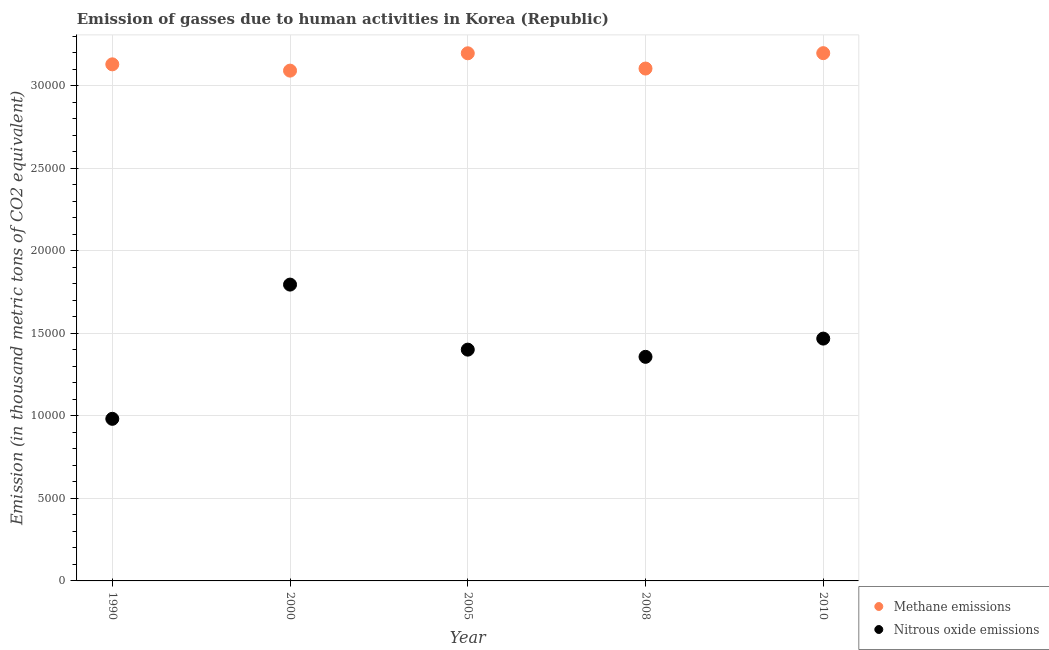How many different coloured dotlines are there?
Offer a terse response. 2. Is the number of dotlines equal to the number of legend labels?
Your answer should be compact. Yes. What is the amount of nitrous oxide emissions in 1990?
Give a very brief answer. 9823.4. Across all years, what is the maximum amount of nitrous oxide emissions?
Offer a terse response. 1.80e+04. Across all years, what is the minimum amount of nitrous oxide emissions?
Make the answer very short. 9823.4. In which year was the amount of nitrous oxide emissions maximum?
Provide a short and direct response. 2000. What is the total amount of methane emissions in the graph?
Offer a very short reply. 1.57e+05. What is the difference between the amount of methane emissions in 2000 and that in 2008?
Your answer should be compact. -126.5. What is the difference between the amount of nitrous oxide emissions in 1990 and the amount of methane emissions in 2000?
Your answer should be compact. -2.11e+04. What is the average amount of nitrous oxide emissions per year?
Ensure brevity in your answer.  1.40e+04. In the year 2008, what is the difference between the amount of methane emissions and amount of nitrous oxide emissions?
Your answer should be very brief. 1.75e+04. What is the ratio of the amount of methane emissions in 1990 to that in 2010?
Your answer should be very brief. 0.98. What is the difference between the highest and the second highest amount of nitrous oxide emissions?
Give a very brief answer. 3272.5. What is the difference between the highest and the lowest amount of nitrous oxide emissions?
Offer a very short reply. 8134.7. In how many years, is the amount of nitrous oxide emissions greater than the average amount of nitrous oxide emissions taken over all years?
Your answer should be compact. 3. Does the amount of methane emissions monotonically increase over the years?
Provide a succinct answer. No. Is the amount of methane emissions strictly greater than the amount of nitrous oxide emissions over the years?
Make the answer very short. Yes. Is the amount of nitrous oxide emissions strictly less than the amount of methane emissions over the years?
Provide a succinct answer. Yes. How many dotlines are there?
Your answer should be very brief. 2. What is the title of the graph?
Ensure brevity in your answer.  Emission of gasses due to human activities in Korea (Republic). Does "Residents" appear as one of the legend labels in the graph?
Make the answer very short. No. What is the label or title of the Y-axis?
Your answer should be compact. Emission (in thousand metric tons of CO2 equivalent). What is the Emission (in thousand metric tons of CO2 equivalent) of Methane emissions in 1990?
Offer a terse response. 3.13e+04. What is the Emission (in thousand metric tons of CO2 equivalent) in Nitrous oxide emissions in 1990?
Offer a terse response. 9823.4. What is the Emission (in thousand metric tons of CO2 equivalent) of Methane emissions in 2000?
Your response must be concise. 3.09e+04. What is the Emission (in thousand metric tons of CO2 equivalent) in Nitrous oxide emissions in 2000?
Make the answer very short. 1.80e+04. What is the Emission (in thousand metric tons of CO2 equivalent) in Methane emissions in 2005?
Make the answer very short. 3.20e+04. What is the Emission (in thousand metric tons of CO2 equivalent) of Nitrous oxide emissions in 2005?
Give a very brief answer. 1.40e+04. What is the Emission (in thousand metric tons of CO2 equivalent) of Methane emissions in 2008?
Your response must be concise. 3.11e+04. What is the Emission (in thousand metric tons of CO2 equivalent) of Nitrous oxide emissions in 2008?
Provide a short and direct response. 1.36e+04. What is the Emission (in thousand metric tons of CO2 equivalent) in Methane emissions in 2010?
Provide a short and direct response. 3.20e+04. What is the Emission (in thousand metric tons of CO2 equivalent) in Nitrous oxide emissions in 2010?
Give a very brief answer. 1.47e+04. Across all years, what is the maximum Emission (in thousand metric tons of CO2 equivalent) of Methane emissions?
Offer a terse response. 3.20e+04. Across all years, what is the maximum Emission (in thousand metric tons of CO2 equivalent) of Nitrous oxide emissions?
Your answer should be very brief. 1.80e+04. Across all years, what is the minimum Emission (in thousand metric tons of CO2 equivalent) of Methane emissions?
Offer a very short reply. 3.09e+04. Across all years, what is the minimum Emission (in thousand metric tons of CO2 equivalent) in Nitrous oxide emissions?
Offer a very short reply. 9823.4. What is the total Emission (in thousand metric tons of CO2 equivalent) in Methane emissions in the graph?
Provide a succinct answer. 1.57e+05. What is the total Emission (in thousand metric tons of CO2 equivalent) of Nitrous oxide emissions in the graph?
Offer a terse response. 7.01e+04. What is the difference between the Emission (in thousand metric tons of CO2 equivalent) in Methane emissions in 1990 and that in 2000?
Offer a very short reply. 381.1. What is the difference between the Emission (in thousand metric tons of CO2 equivalent) of Nitrous oxide emissions in 1990 and that in 2000?
Your response must be concise. -8134.7. What is the difference between the Emission (in thousand metric tons of CO2 equivalent) of Methane emissions in 1990 and that in 2005?
Your answer should be very brief. -669.8. What is the difference between the Emission (in thousand metric tons of CO2 equivalent) of Nitrous oxide emissions in 1990 and that in 2005?
Ensure brevity in your answer.  -4193. What is the difference between the Emission (in thousand metric tons of CO2 equivalent) in Methane emissions in 1990 and that in 2008?
Provide a succinct answer. 254.6. What is the difference between the Emission (in thousand metric tons of CO2 equivalent) in Nitrous oxide emissions in 1990 and that in 2008?
Ensure brevity in your answer.  -3756.8. What is the difference between the Emission (in thousand metric tons of CO2 equivalent) of Methane emissions in 1990 and that in 2010?
Make the answer very short. -677.7. What is the difference between the Emission (in thousand metric tons of CO2 equivalent) in Nitrous oxide emissions in 1990 and that in 2010?
Your answer should be very brief. -4862.2. What is the difference between the Emission (in thousand metric tons of CO2 equivalent) in Methane emissions in 2000 and that in 2005?
Keep it short and to the point. -1050.9. What is the difference between the Emission (in thousand metric tons of CO2 equivalent) in Nitrous oxide emissions in 2000 and that in 2005?
Your answer should be compact. 3941.7. What is the difference between the Emission (in thousand metric tons of CO2 equivalent) of Methane emissions in 2000 and that in 2008?
Give a very brief answer. -126.5. What is the difference between the Emission (in thousand metric tons of CO2 equivalent) in Nitrous oxide emissions in 2000 and that in 2008?
Make the answer very short. 4377.9. What is the difference between the Emission (in thousand metric tons of CO2 equivalent) in Methane emissions in 2000 and that in 2010?
Offer a very short reply. -1058.8. What is the difference between the Emission (in thousand metric tons of CO2 equivalent) of Nitrous oxide emissions in 2000 and that in 2010?
Offer a terse response. 3272.5. What is the difference between the Emission (in thousand metric tons of CO2 equivalent) in Methane emissions in 2005 and that in 2008?
Keep it short and to the point. 924.4. What is the difference between the Emission (in thousand metric tons of CO2 equivalent) of Nitrous oxide emissions in 2005 and that in 2008?
Ensure brevity in your answer.  436.2. What is the difference between the Emission (in thousand metric tons of CO2 equivalent) in Nitrous oxide emissions in 2005 and that in 2010?
Provide a succinct answer. -669.2. What is the difference between the Emission (in thousand metric tons of CO2 equivalent) in Methane emissions in 2008 and that in 2010?
Offer a very short reply. -932.3. What is the difference between the Emission (in thousand metric tons of CO2 equivalent) of Nitrous oxide emissions in 2008 and that in 2010?
Provide a short and direct response. -1105.4. What is the difference between the Emission (in thousand metric tons of CO2 equivalent) of Methane emissions in 1990 and the Emission (in thousand metric tons of CO2 equivalent) of Nitrous oxide emissions in 2000?
Offer a terse response. 1.33e+04. What is the difference between the Emission (in thousand metric tons of CO2 equivalent) of Methane emissions in 1990 and the Emission (in thousand metric tons of CO2 equivalent) of Nitrous oxide emissions in 2005?
Provide a short and direct response. 1.73e+04. What is the difference between the Emission (in thousand metric tons of CO2 equivalent) of Methane emissions in 1990 and the Emission (in thousand metric tons of CO2 equivalent) of Nitrous oxide emissions in 2008?
Provide a succinct answer. 1.77e+04. What is the difference between the Emission (in thousand metric tons of CO2 equivalent) of Methane emissions in 1990 and the Emission (in thousand metric tons of CO2 equivalent) of Nitrous oxide emissions in 2010?
Offer a very short reply. 1.66e+04. What is the difference between the Emission (in thousand metric tons of CO2 equivalent) of Methane emissions in 2000 and the Emission (in thousand metric tons of CO2 equivalent) of Nitrous oxide emissions in 2005?
Give a very brief answer. 1.69e+04. What is the difference between the Emission (in thousand metric tons of CO2 equivalent) of Methane emissions in 2000 and the Emission (in thousand metric tons of CO2 equivalent) of Nitrous oxide emissions in 2008?
Provide a short and direct response. 1.73e+04. What is the difference between the Emission (in thousand metric tons of CO2 equivalent) of Methane emissions in 2000 and the Emission (in thousand metric tons of CO2 equivalent) of Nitrous oxide emissions in 2010?
Offer a very short reply. 1.62e+04. What is the difference between the Emission (in thousand metric tons of CO2 equivalent) of Methane emissions in 2005 and the Emission (in thousand metric tons of CO2 equivalent) of Nitrous oxide emissions in 2008?
Ensure brevity in your answer.  1.84e+04. What is the difference between the Emission (in thousand metric tons of CO2 equivalent) in Methane emissions in 2005 and the Emission (in thousand metric tons of CO2 equivalent) in Nitrous oxide emissions in 2010?
Keep it short and to the point. 1.73e+04. What is the difference between the Emission (in thousand metric tons of CO2 equivalent) of Methane emissions in 2008 and the Emission (in thousand metric tons of CO2 equivalent) of Nitrous oxide emissions in 2010?
Your answer should be compact. 1.64e+04. What is the average Emission (in thousand metric tons of CO2 equivalent) in Methane emissions per year?
Provide a short and direct response. 3.14e+04. What is the average Emission (in thousand metric tons of CO2 equivalent) in Nitrous oxide emissions per year?
Your response must be concise. 1.40e+04. In the year 1990, what is the difference between the Emission (in thousand metric tons of CO2 equivalent) of Methane emissions and Emission (in thousand metric tons of CO2 equivalent) of Nitrous oxide emissions?
Your response must be concise. 2.15e+04. In the year 2000, what is the difference between the Emission (in thousand metric tons of CO2 equivalent) of Methane emissions and Emission (in thousand metric tons of CO2 equivalent) of Nitrous oxide emissions?
Ensure brevity in your answer.  1.30e+04. In the year 2005, what is the difference between the Emission (in thousand metric tons of CO2 equivalent) of Methane emissions and Emission (in thousand metric tons of CO2 equivalent) of Nitrous oxide emissions?
Offer a terse response. 1.80e+04. In the year 2008, what is the difference between the Emission (in thousand metric tons of CO2 equivalent) of Methane emissions and Emission (in thousand metric tons of CO2 equivalent) of Nitrous oxide emissions?
Keep it short and to the point. 1.75e+04. In the year 2010, what is the difference between the Emission (in thousand metric tons of CO2 equivalent) in Methane emissions and Emission (in thousand metric tons of CO2 equivalent) in Nitrous oxide emissions?
Your response must be concise. 1.73e+04. What is the ratio of the Emission (in thousand metric tons of CO2 equivalent) of Methane emissions in 1990 to that in 2000?
Your response must be concise. 1.01. What is the ratio of the Emission (in thousand metric tons of CO2 equivalent) in Nitrous oxide emissions in 1990 to that in 2000?
Offer a very short reply. 0.55. What is the ratio of the Emission (in thousand metric tons of CO2 equivalent) of Methane emissions in 1990 to that in 2005?
Give a very brief answer. 0.98. What is the ratio of the Emission (in thousand metric tons of CO2 equivalent) of Nitrous oxide emissions in 1990 to that in 2005?
Your response must be concise. 0.7. What is the ratio of the Emission (in thousand metric tons of CO2 equivalent) in Methane emissions in 1990 to that in 2008?
Provide a short and direct response. 1.01. What is the ratio of the Emission (in thousand metric tons of CO2 equivalent) in Nitrous oxide emissions in 1990 to that in 2008?
Provide a succinct answer. 0.72. What is the ratio of the Emission (in thousand metric tons of CO2 equivalent) in Methane emissions in 1990 to that in 2010?
Offer a terse response. 0.98. What is the ratio of the Emission (in thousand metric tons of CO2 equivalent) in Nitrous oxide emissions in 1990 to that in 2010?
Make the answer very short. 0.67. What is the ratio of the Emission (in thousand metric tons of CO2 equivalent) in Methane emissions in 2000 to that in 2005?
Your answer should be very brief. 0.97. What is the ratio of the Emission (in thousand metric tons of CO2 equivalent) in Nitrous oxide emissions in 2000 to that in 2005?
Offer a terse response. 1.28. What is the ratio of the Emission (in thousand metric tons of CO2 equivalent) of Nitrous oxide emissions in 2000 to that in 2008?
Your answer should be compact. 1.32. What is the ratio of the Emission (in thousand metric tons of CO2 equivalent) of Methane emissions in 2000 to that in 2010?
Provide a succinct answer. 0.97. What is the ratio of the Emission (in thousand metric tons of CO2 equivalent) in Nitrous oxide emissions in 2000 to that in 2010?
Give a very brief answer. 1.22. What is the ratio of the Emission (in thousand metric tons of CO2 equivalent) in Methane emissions in 2005 to that in 2008?
Offer a terse response. 1.03. What is the ratio of the Emission (in thousand metric tons of CO2 equivalent) in Nitrous oxide emissions in 2005 to that in 2008?
Offer a very short reply. 1.03. What is the ratio of the Emission (in thousand metric tons of CO2 equivalent) in Nitrous oxide emissions in 2005 to that in 2010?
Give a very brief answer. 0.95. What is the ratio of the Emission (in thousand metric tons of CO2 equivalent) of Methane emissions in 2008 to that in 2010?
Provide a short and direct response. 0.97. What is the ratio of the Emission (in thousand metric tons of CO2 equivalent) in Nitrous oxide emissions in 2008 to that in 2010?
Offer a very short reply. 0.92. What is the difference between the highest and the second highest Emission (in thousand metric tons of CO2 equivalent) in Methane emissions?
Provide a short and direct response. 7.9. What is the difference between the highest and the second highest Emission (in thousand metric tons of CO2 equivalent) in Nitrous oxide emissions?
Ensure brevity in your answer.  3272.5. What is the difference between the highest and the lowest Emission (in thousand metric tons of CO2 equivalent) of Methane emissions?
Ensure brevity in your answer.  1058.8. What is the difference between the highest and the lowest Emission (in thousand metric tons of CO2 equivalent) in Nitrous oxide emissions?
Give a very brief answer. 8134.7. 